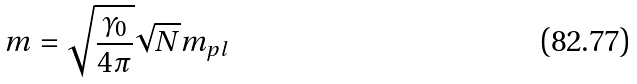Convert formula to latex. <formula><loc_0><loc_0><loc_500><loc_500>m = \sqrt { \frac { \gamma _ { 0 } } { 4 \pi } } \sqrt { N } m _ { p l }</formula> 